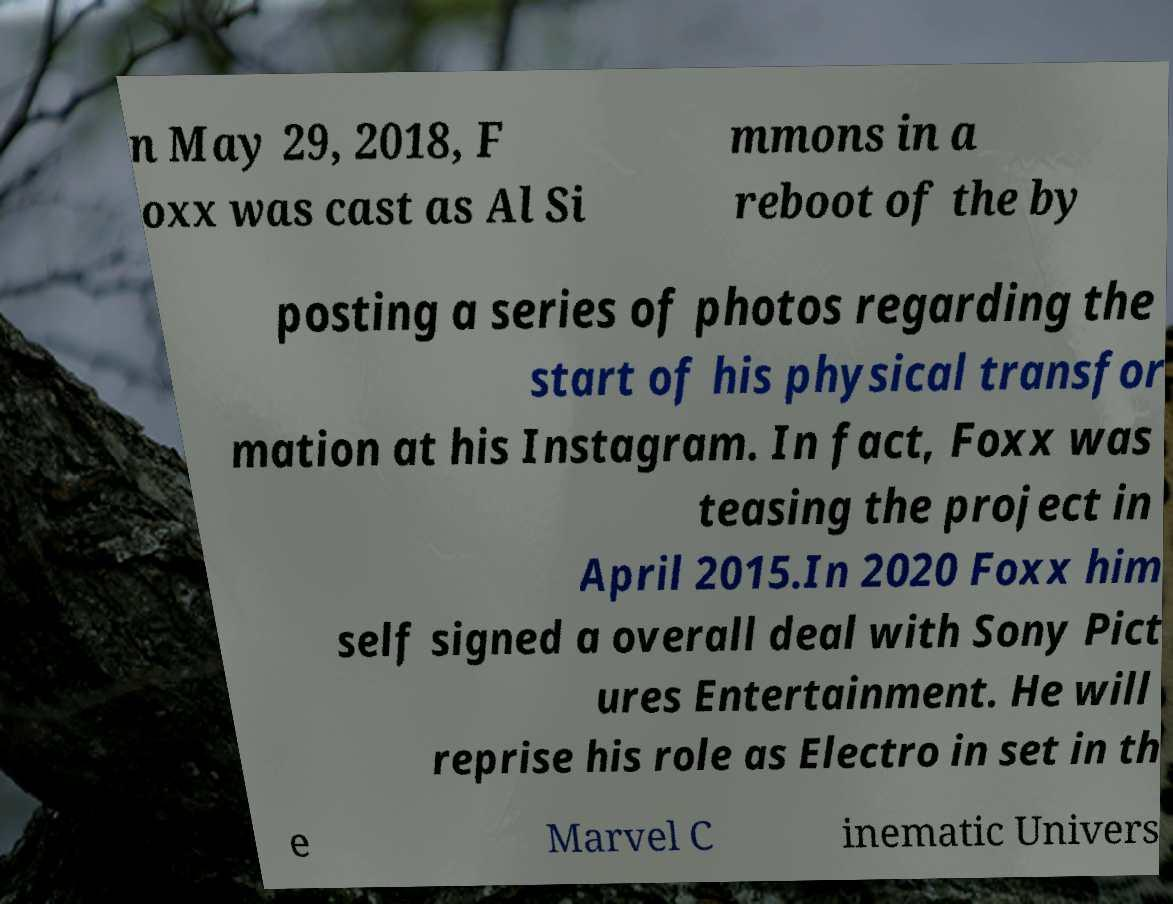What messages or text are displayed in this image? I need them in a readable, typed format. n May 29, 2018, F oxx was cast as Al Si mmons in a reboot of the by posting a series of photos regarding the start of his physical transfor mation at his Instagram. In fact, Foxx was teasing the project in April 2015.In 2020 Foxx him self signed a overall deal with Sony Pict ures Entertainment. He will reprise his role as Electro in set in th e Marvel C inematic Univers 